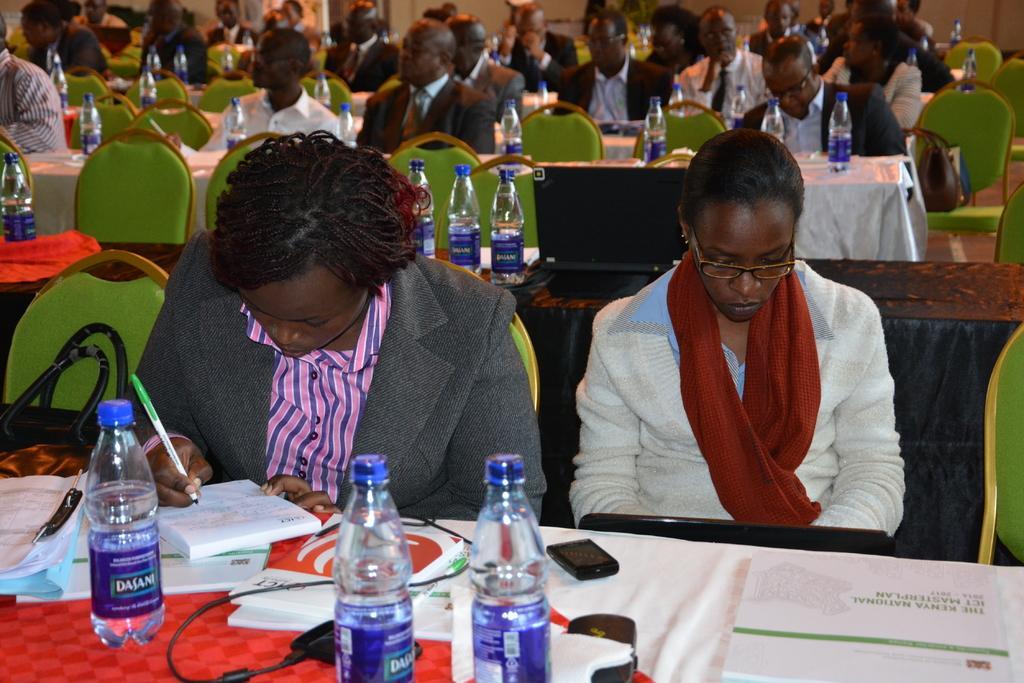How would you summarize this image in a sentence or two? In this picture we can see some persons sitting on the green colored chairs. This is the table, on the table there is a cloth, mobile, bottles, and book. And she is writing something on the book. 